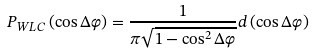<formula> <loc_0><loc_0><loc_500><loc_500>P _ { W L C } \left ( \cos \Delta \varphi \right ) = \frac { 1 } { \pi \sqrt { 1 - \cos ^ { 2 } \Delta \varphi } } d \left ( \cos \Delta \varphi \right )</formula> 